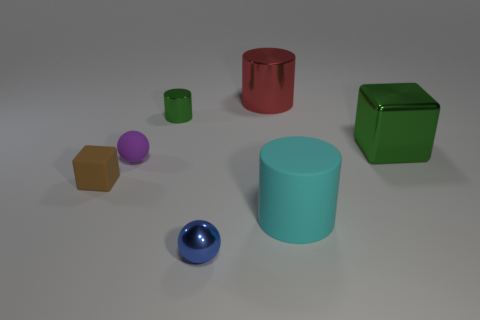Are any large red matte blocks visible?
Your answer should be compact. No. What color is the tiny sphere that is in front of the small brown rubber cube?
Keep it short and to the point. Blue. There is a metal cube; is it the same size as the metallic object that is in front of the small purple object?
Your answer should be very brief. No. What is the size of the cylinder that is both right of the metal ball and behind the matte cylinder?
Your answer should be very brief. Large. Are there any other gray cylinders made of the same material as the tiny cylinder?
Provide a succinct answer. No. The tiny blue shiny thing is what shape?
Offer a terse response. Sphere. Do the red object and the brown object have the same size?
Your answer should be very brief. No. How many other things are there of the same shape as the red thing?
Give a very brief answer. 2. What is the shape of the green shiny thing to the right of the tiny green object?
Your response must be concise. Cube. There is a small metal object behind the cyan rubber cylinder; is its shape the same as the shiny object to the right of the big red metallic cylinder?
Your answer should be very brief. No. 